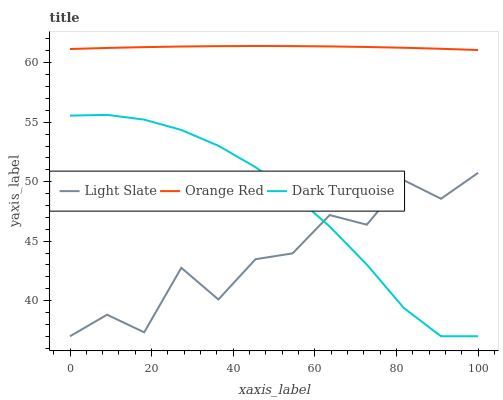Does Light Slate have the minimum area under the curve?
Answer yes or no. Yes. Does Orange Red have the maximum area under the curve?
Answer yes or no. Yes. Does Dark Turquoise have the minimum area under the curve?
Answer yes or no. No. Does Dark Turquoise have the maximum area under the curve?
Answer yes or no. No. Is Orange Red the smoothest?
Answer yes or no. Yes. Is Light Slate the roughest?
Answer yes or no. Yes. Is Dark Turquoise the smoothest?
Answer yes or no. No. Is Dark Turquoise the roughest?
Answer yes or no. No. Does Light Slate have the lowest value?
Answer yes or no. Yes. Does Orange Red have the lowest value?
Answer yes or no. No. Does Orange Red have the highest value?
Answer yes or no. Yes. Does Dark Turquoise have the highest value?
Answer yes or no. No. Is Dark Turquoise less than Orange Red?
Answer yes or no. Yes. Is Orange Red greater than Dark Turquoise?
Answer yes or no. Yes. Does Dark Turquoise intersect Light Slate?
Answer yes or no. Yes. Is Dark Turquoise less than Light Slate?
Answer yes or no. No. Is Dark Turquoise greater than Light Slate?
Answer yes or no. No. Does Dark Turquoise intersect Orange Red?
Answer yes or no. No. 